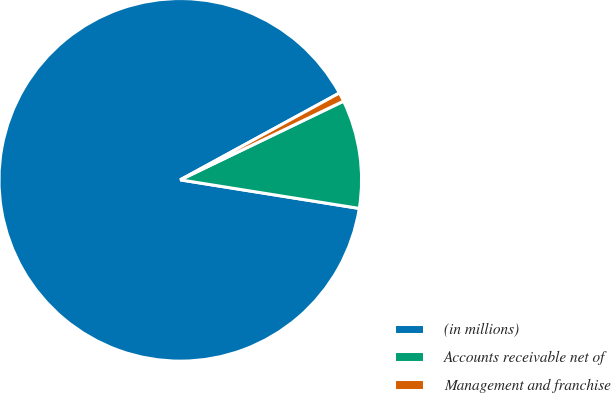<chart> <loc_0><loc_0><loc_500><loc_500><pie_chart><fcel>(in millions)<fcel>Accounts receivable net of<fcel>Management and franchise<nl><fcel>89.53%<fcel>9.67%<fcel>0.8%<nl></chart> 